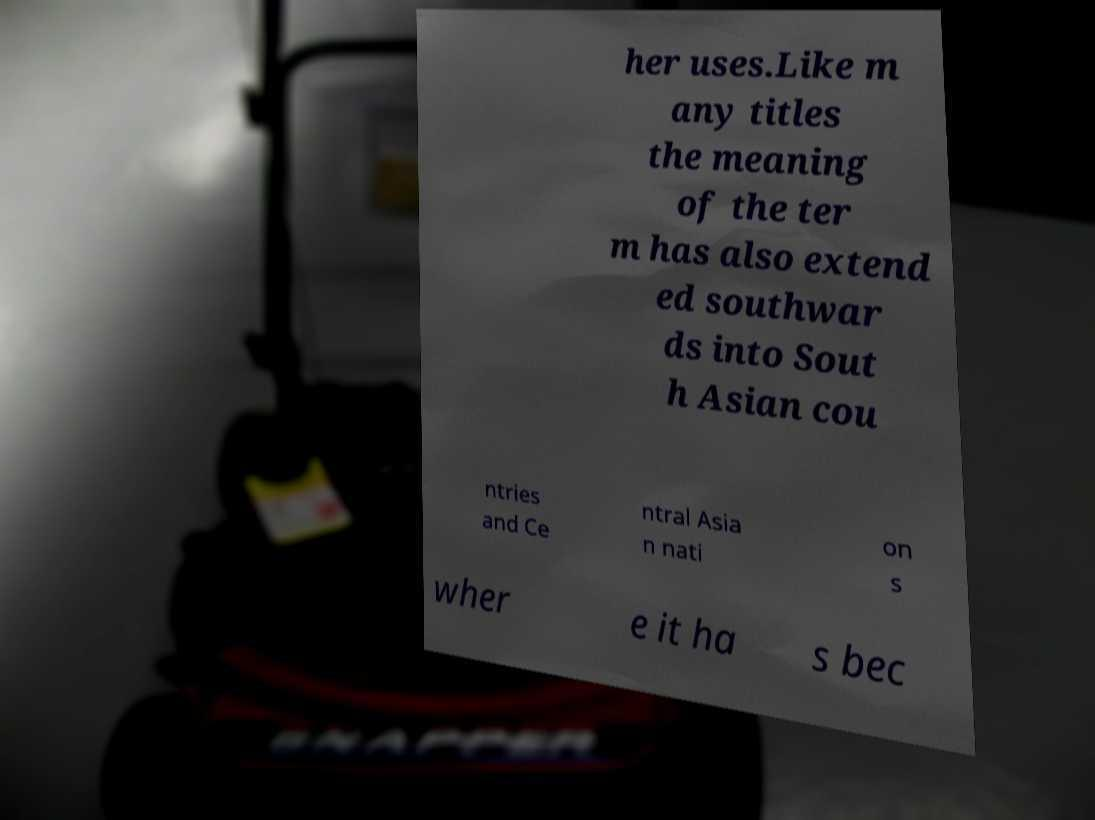Could you extract and type out the text from this image? her uses.Like m any titles the meaning of the ter m has also extend ed southwar ds into Sout h Asian cou ntries and Ce ntral Asia n nati on s wher e it ha s bec 